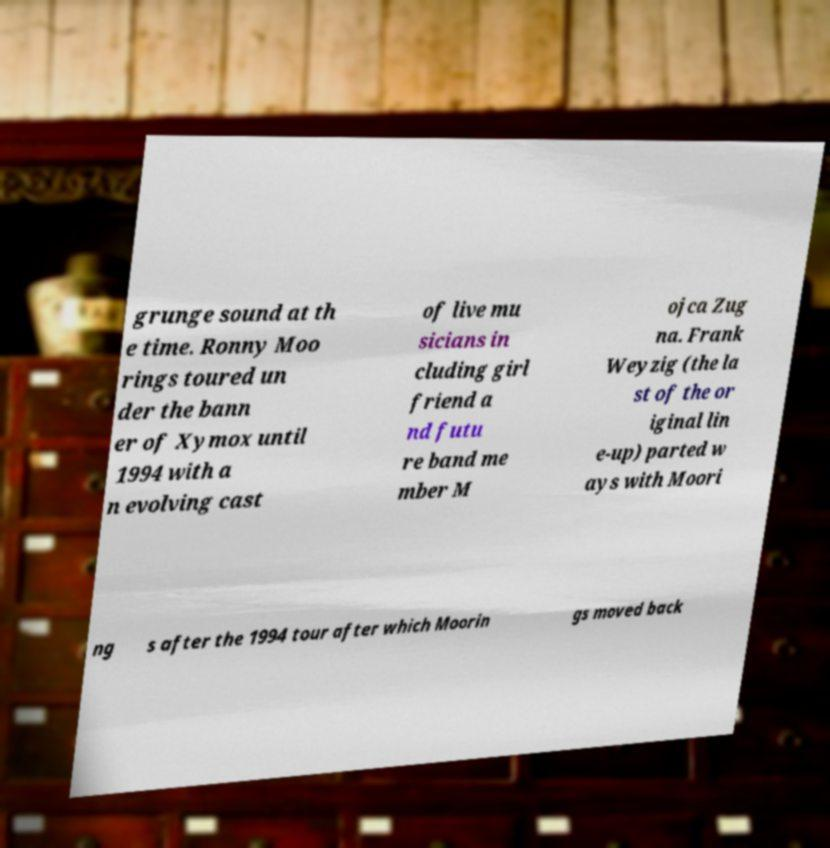Can you read and provide the text displayed in the image?This photo seems to have some interesting text. Can you extract and type it out for me? grunge sound at th e time. Ronny Moo rings toured un der the bann er of Xymox until 1994 with a n evolving cast of live mu sicians in cluding girl friend a nd futu re band me mber M ojca Zug na. Frank Weyzig (the la st of the or iginal lin e-up) parted w ays with Moori ng s after the 1994 tour after which Moorin gs moved back 